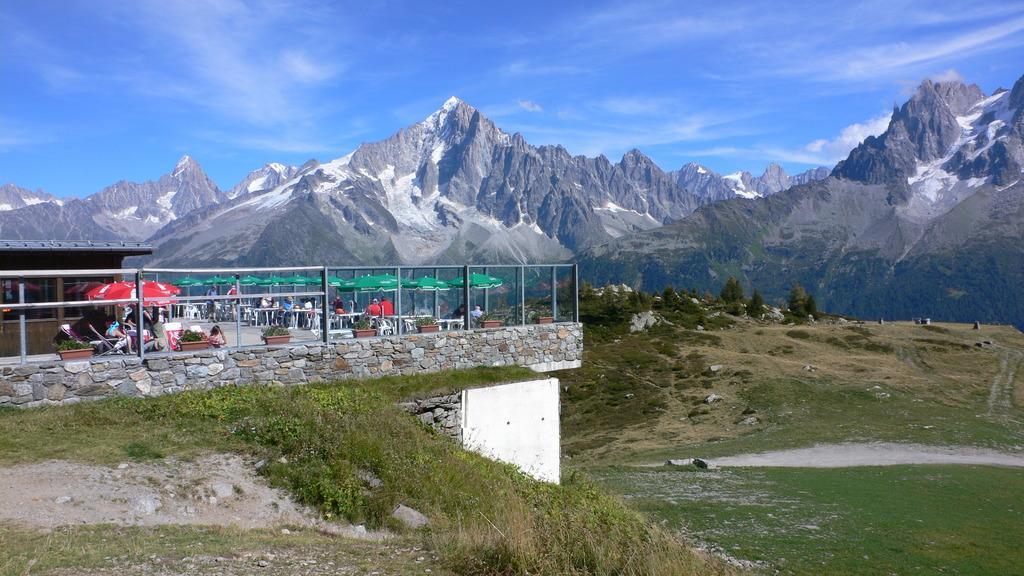In one or two sentences, can you explain what this image depicts? In this picture there are tables and chairs under the umbrellas on terrace, on the left side of the image, there are people those who are sitting on the chairs and there is greenery in the image and there are mountains in the background area of the image. 